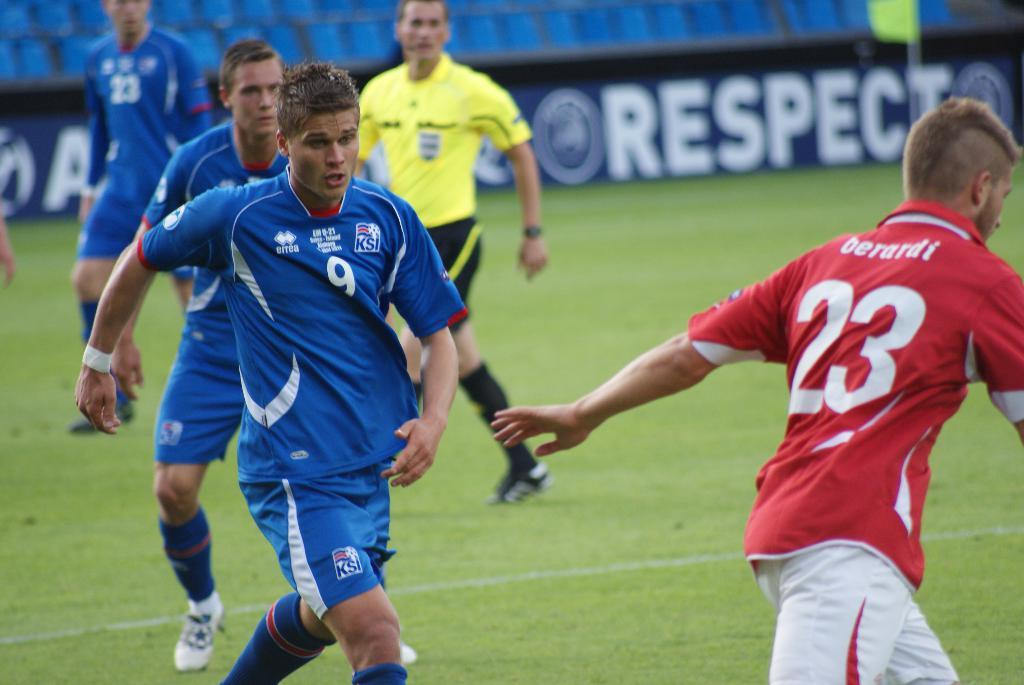<image>
Share a concise interpretation of the image provided. Soccer player with number 23 is being followed by number 9. 